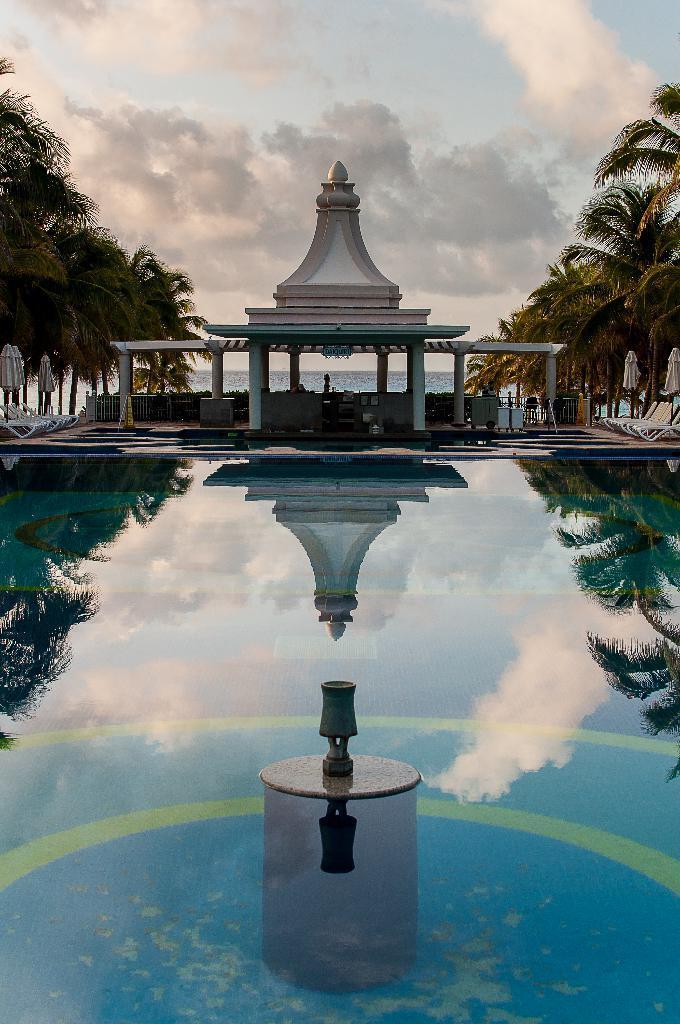Could you give a brief overview of what you see in this image? This image consists of water. It looks like a swimming pool. On the left and right, there are trees. At the top, there are clouds in the sky. 